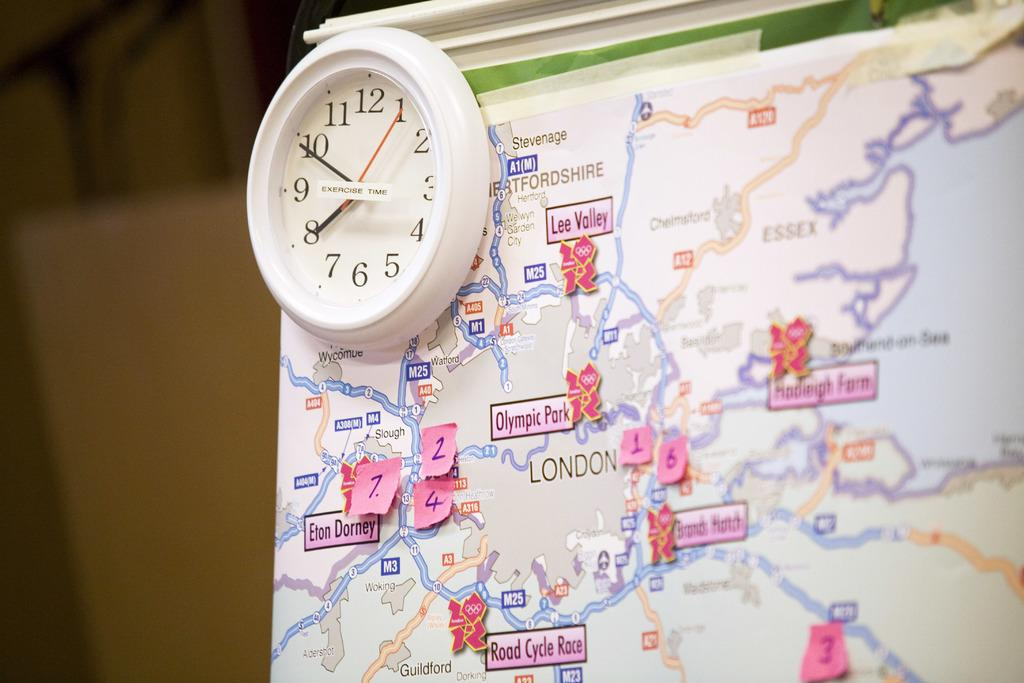<image>
Relay a brief, clear account of the picture shown. A small white label that says exercise time is pasted on the front of a wall clock. 